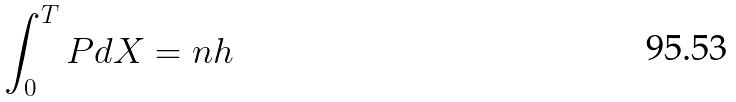Convert formula to latex. <formula><loc_0><loc_0><loc_500><loc_500>\int _ { 0 } ^ { T } P d X = n h</formula> 